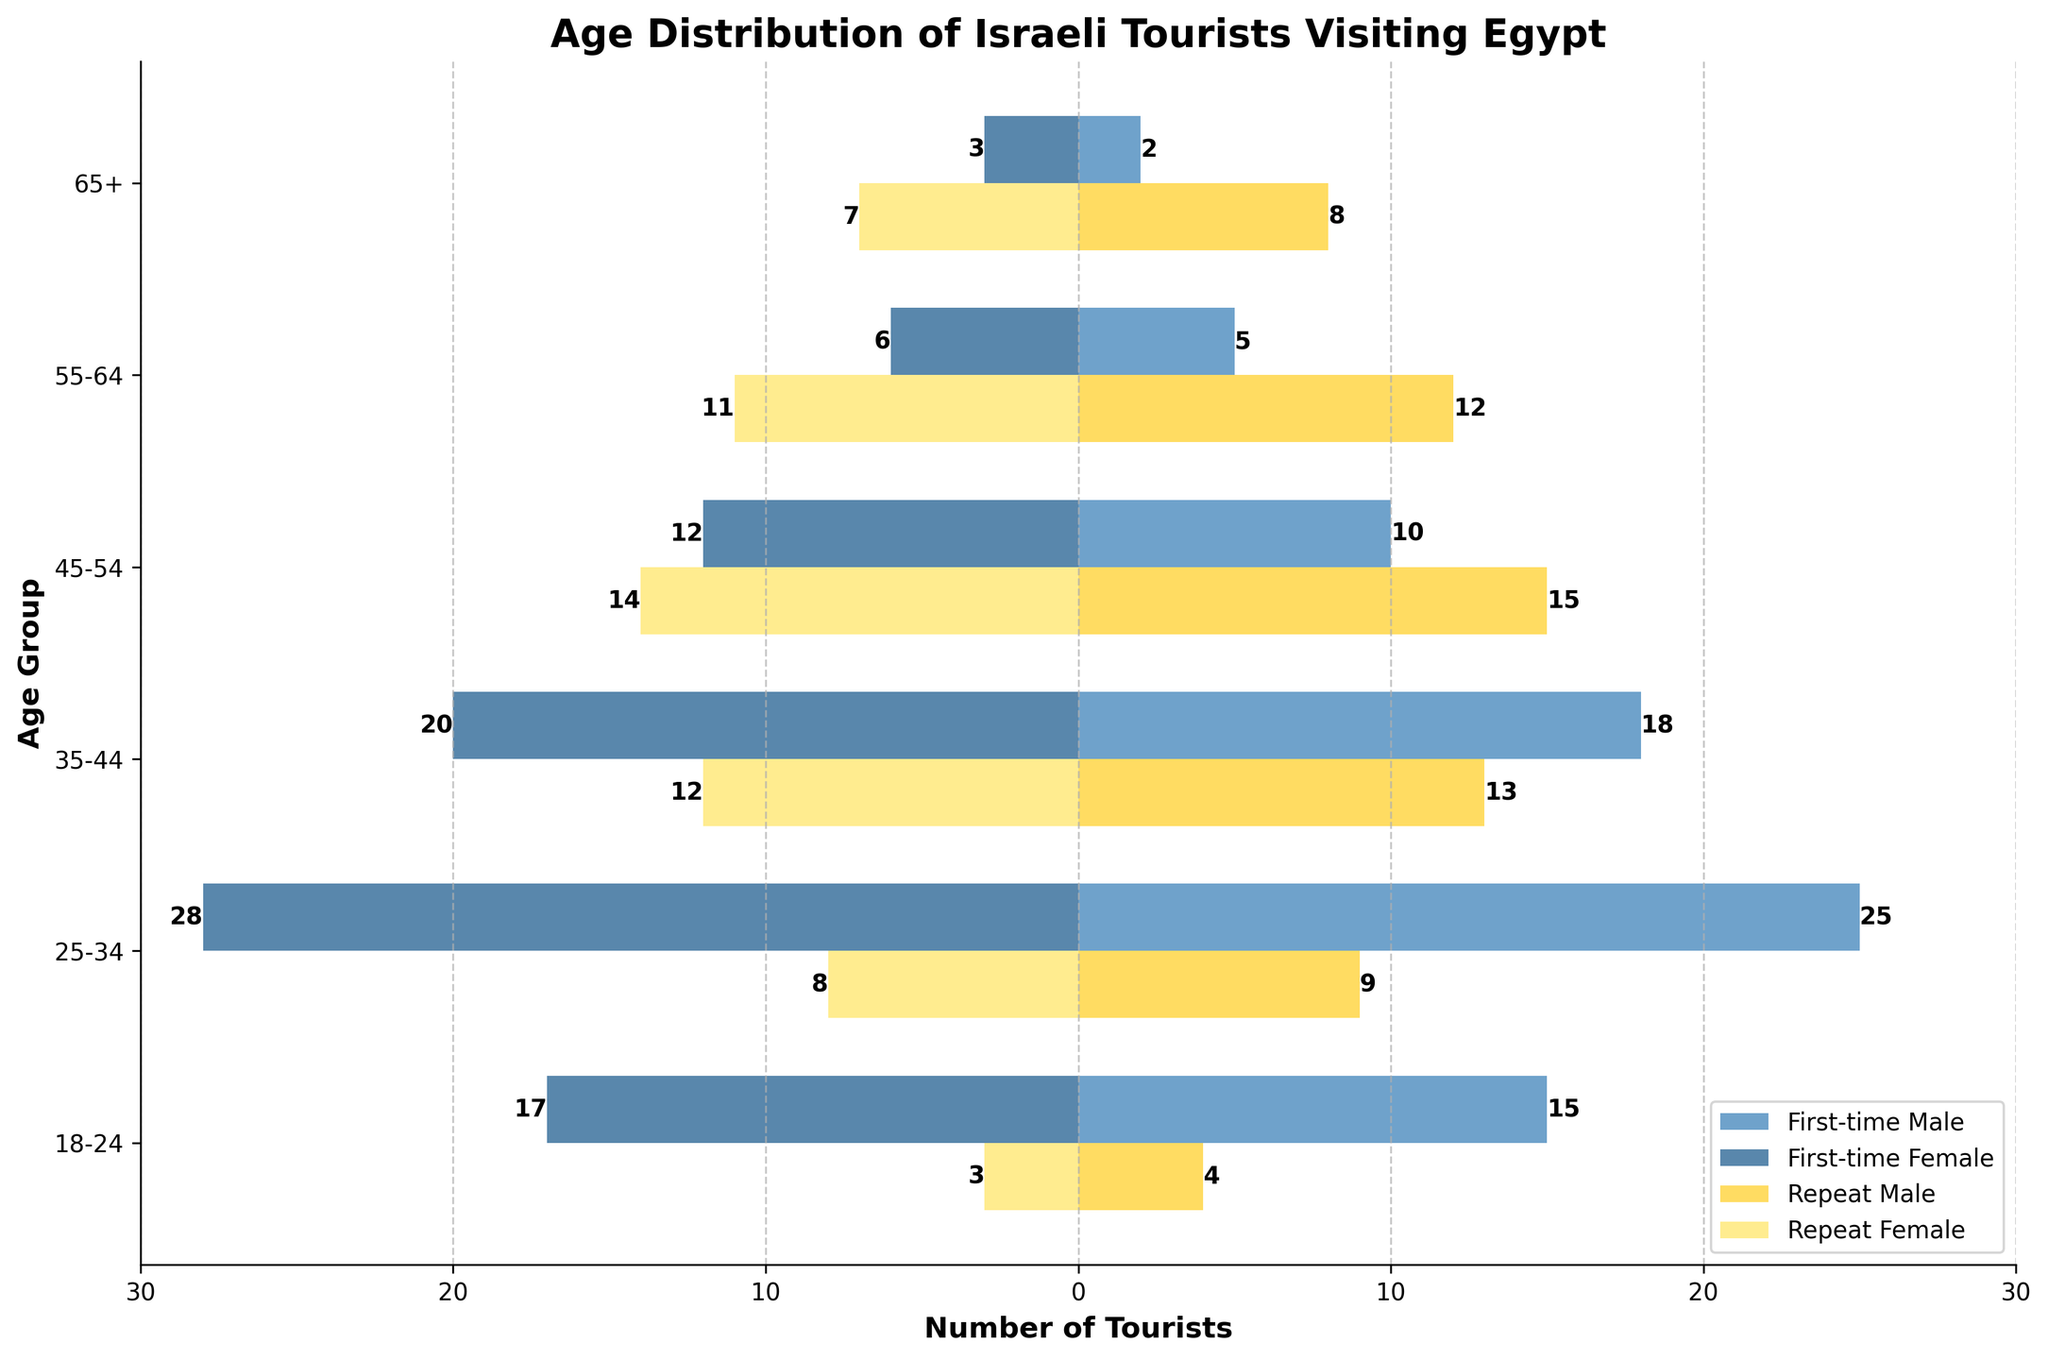What is the title of the figure? Look at the top of the figure. The title is written there.
Answer: Age Distribution of Israeli Tourists Visiting Egypt Which age group has the highest number of first-time male visitors? From the plot, observe which horizontal bar in the first-time male category extends the furthest to the right.
Answer: 25-34 In the age group 35-44, how many more first-time male visitors are there compared to repeat male travelers? The first-time male visitors in the 35-44 age group are 18, and repeat male travelers are 13. Subtract the count of repeat travelers from first-time visitors: 18 - 13 = 5.
Answer: 5 Which group has more visitors in the 45-54 age group, first-time female visitors or repeat female travelers? Compare the lengths of the bars for first-time female visitors and repeat female travelers in the 45-54 age group.
Answer: First-time female visitors What is the total number of repeat travelers in the 55-64 age group? Add the number of repeat male travelers and repeat female travelers in the 55-64 age group: 12 (male) + 11 (female) = 23.
Answer: 23 Compare the number of tourists over the age of 65: More first-time visitors or more repeat travelers? Sum the totals for first-time visitors (2 male + 3 female = 5) and repeat travelers (8 male + 7 female = 15) over the age of 65.
Answer: Repeat travelers How does the number of first-time female visitors in the 25-34 age group compare to the number of repeat female travelers in the same age group? Compare the lengths of the respective bars for female visitors and travelers in the 25-34 age group.
Answer: First-time female visitors are more What age group has the smallest difference between first-time and repeat male travelers? Calculate the absolute difference between first-time and repeat male travelers for each age group, then identify the smallest one. For example, 18-13=5 for 35-44, 15-4=11 for 18-24, etc.
Answer: 35-44 What is the predominant gender among first-time visitors in the age group 18-24? Compare the lengths of the bars representing first-time male and female visitors in the age group 18-24.
Answer: Female In the age group 18-24, how many more first-time visitors are there compared to repeat travelers? Sum the male and female first-time visitors (15 + 17 = 32) and repeat travelers (4 + 3 = 7). Then compute the difference: 32 - 7 = 25.
Answer: 25 